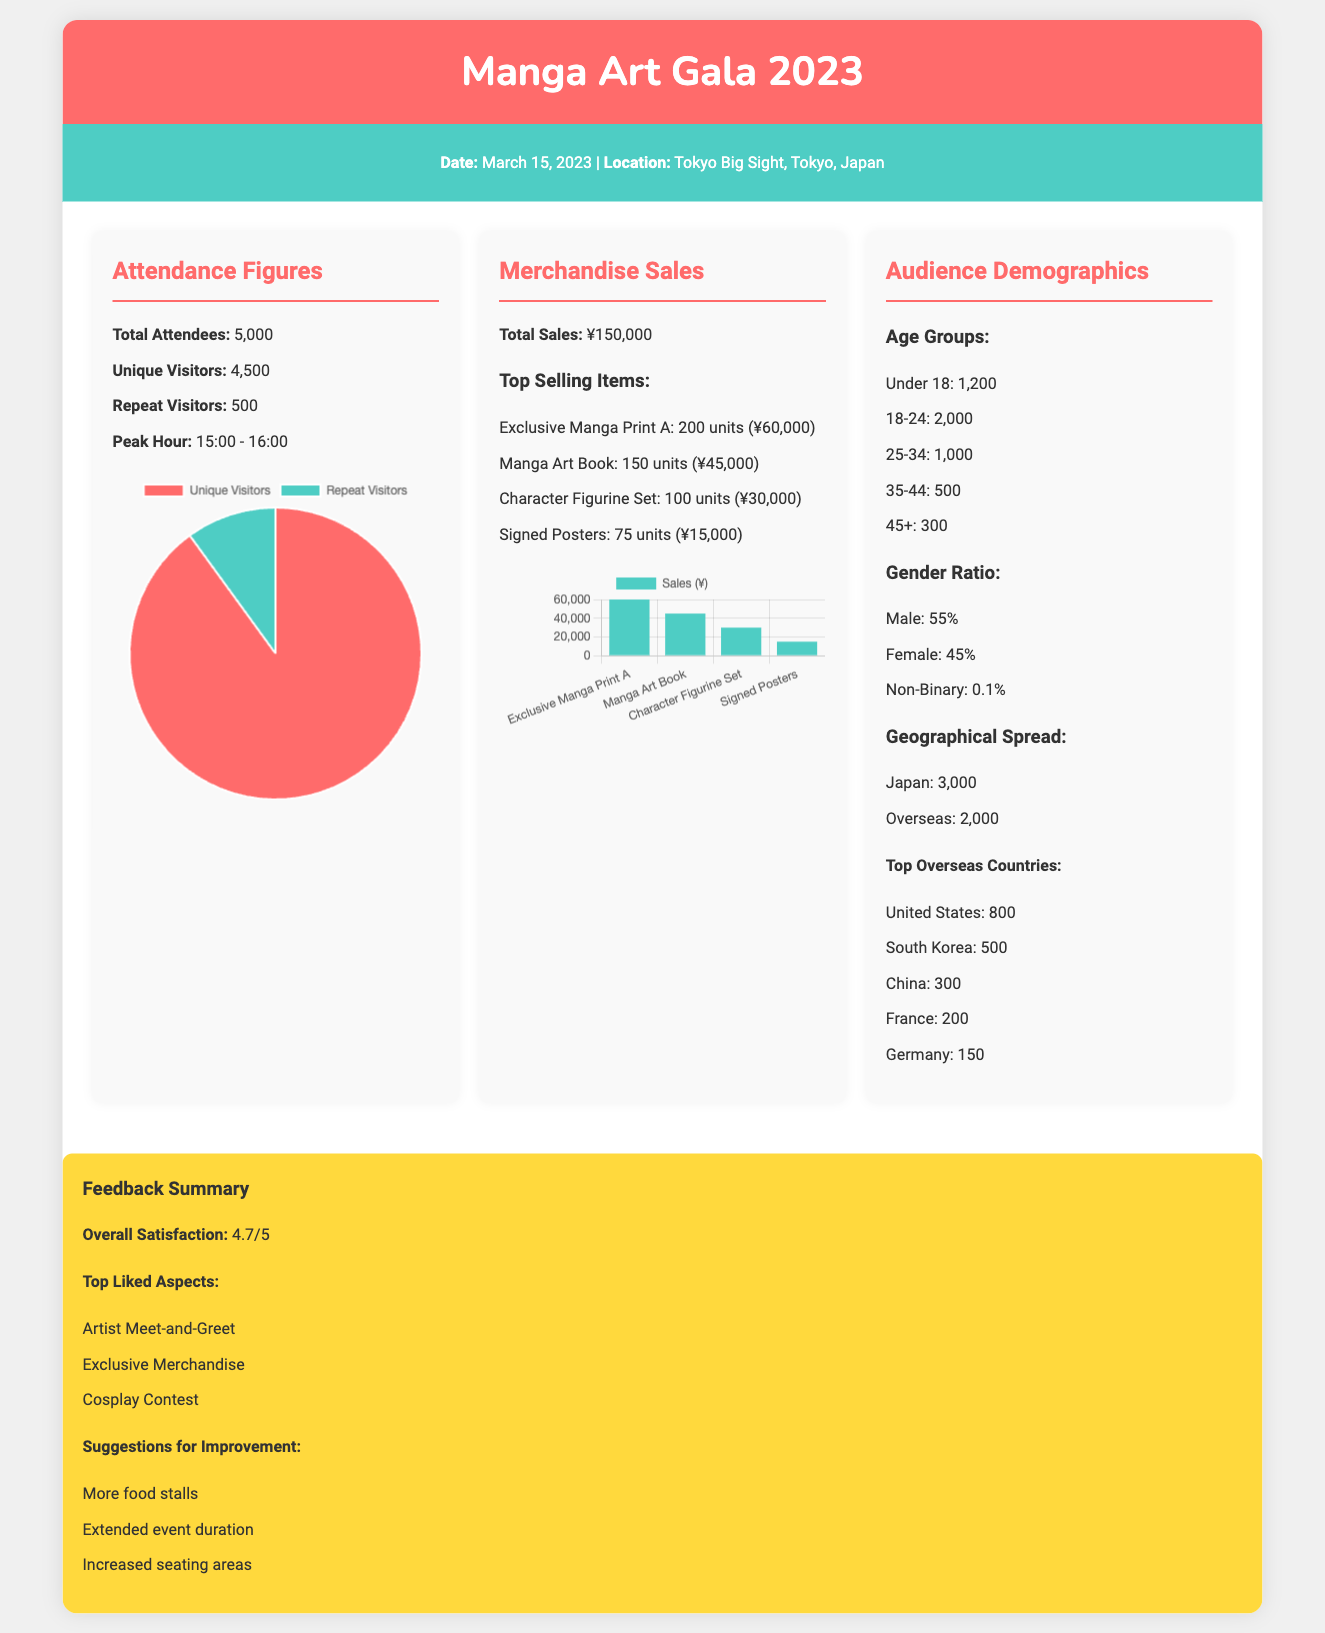What is the date of the event? The date of the event is specified in the document.
Answer: March 15, 2023 What is the total number of attendees? The total number of attendees is listed under Attendance Figures.
Answer: 5,000 What was the peak hour for attendance? The peak hour for attendance is indicated in the Attendance Figures section.
Answer: 15:00 - 16:00 What was the total merchandise sales amount? The total sales amount is provided in the Merchandise Sales section.
Answer: ¥150,000 Which item had the highest sales? The item with the highest sales is identified in the Merchandise Sales section.
Answer: Exclusive Manga Print A What percentage of attendees were male? The male percentage is mentioned in the Audience Demographics section.
Answer: 55% How many attendees were aged 18-24? The number of attendees in the 18-24 age group is specified in the Audience Demographics.
Answer: 2,000 What is the overall satisfaction rating? The overall satisfaction rating is given in the Feedback Summary.
Answer: 4.7/5 What is one suggestion for improvement? A suggestion for improvement is listed under the Feedback Summary.
Answer: More food stalls 